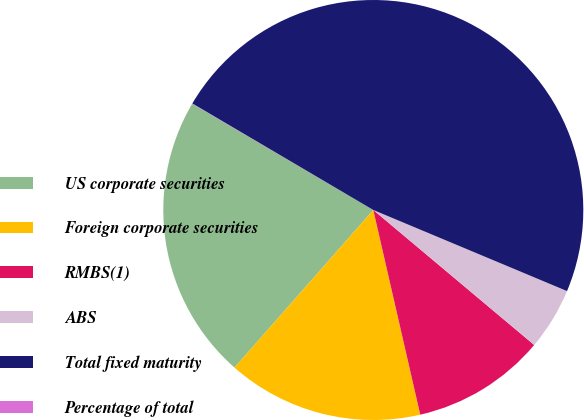<chart> <loc_0><loc_0><loc_500><loc_500><pie_chart><fcel>US corporate securities<fcel>Foreign corporate securities<fcel>RMBS(1)<fcel>ABS<fcel>Total fixed maturity<fcel>Percentage of total<nl><fcel>21.95%<fcel>15.08%<fcel>10.3%<fcel>4.8%<fcel>47.84%<fcel>0.02%<nl></chart> 